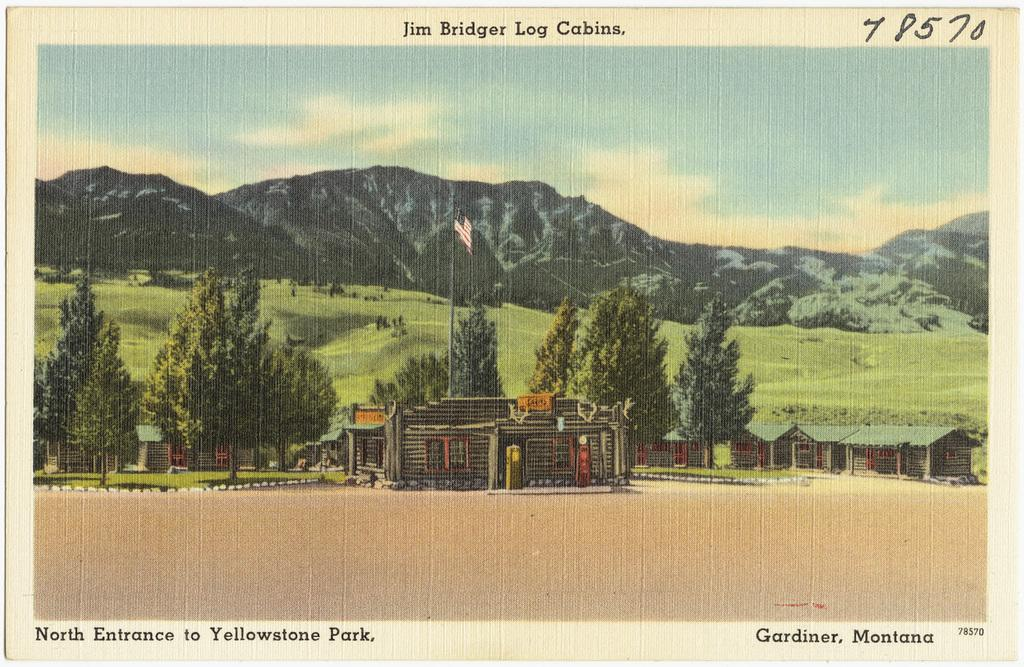What is the main subject of the image? There is a picture of a building in the image. What can be seen around the building? There are trees surrounding the building. What is on top of the building? There is a flag on top of the building. What type of vegetation is visible in the image? There are more trees visible in the image. What is the ground made of in the image? The ground appears to be grassy. What can be seen in the distance in the image? There are mountains visible in the background. What type of silk is being used to make the hobbies visible in the image? There is no silk or hobbies present in the image; it features a building with trees, a flag, and mountains in the background. 